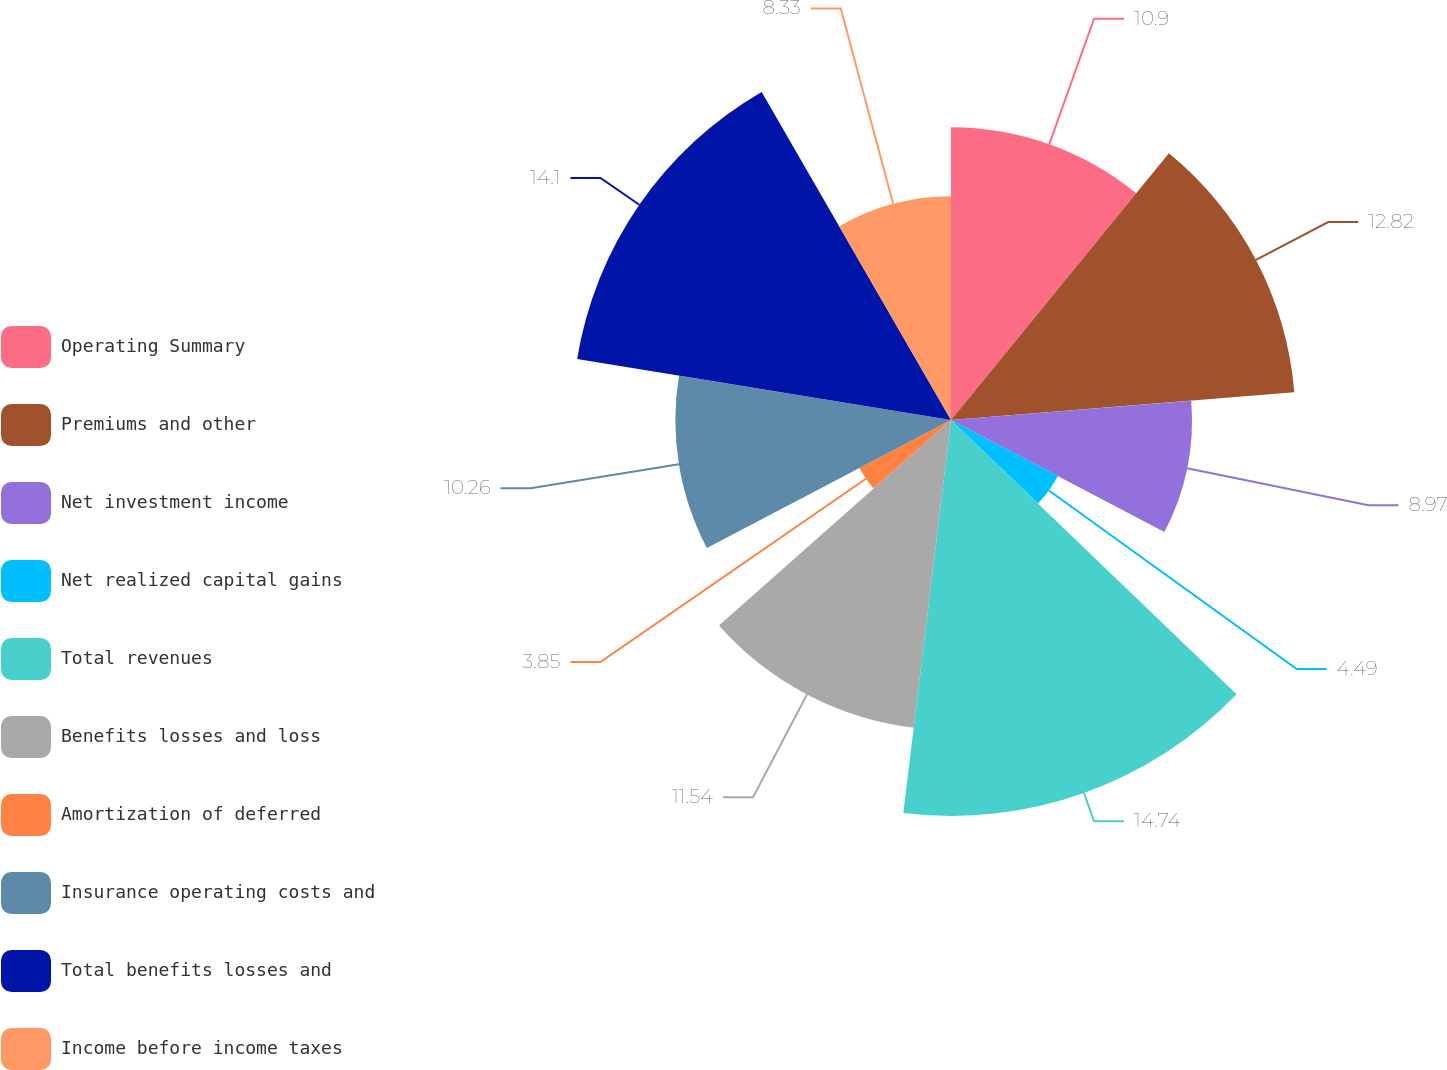<chart> <loc_0><loc_0><loc_500><loc_500><pie_chart><fcel>Operating Summary<fcel>Premiums and other<fcel>Net investment income<fcel>Net realized capital gains<fcel>Total revenues<fcel>Benefits losses and loss<fcel>Amortization of deferred<fcel>Insurance operating costs and<fcel>Total benefits losses and<fcel>Income before income taxes<nl><fcel>10.9%<fcel>12.82%<fcel>8.97%<fcel>4.49%<fcel>14.74%<fcel>11.54%<fcel>3.85%<fcel>10.26%<fcel>14.1%<fcel>8.33%<nl></chart> 